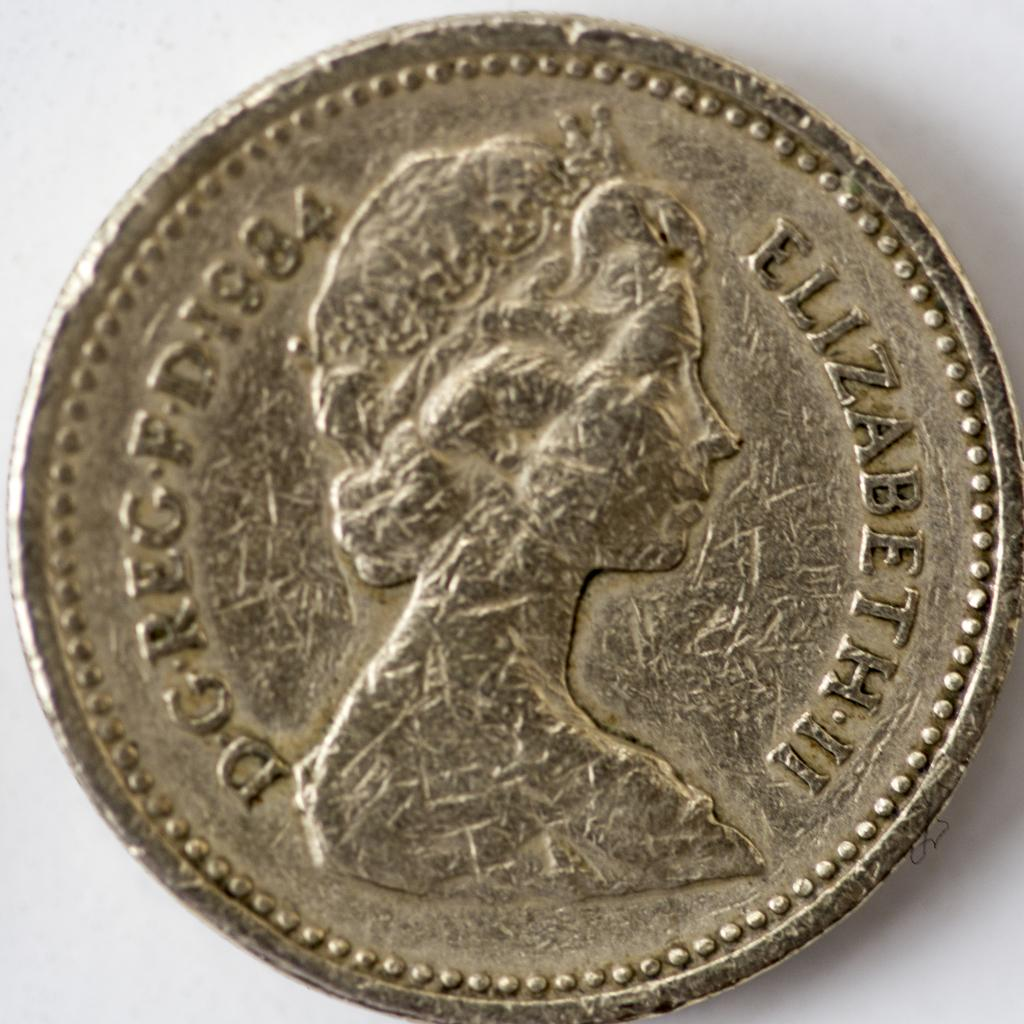Provide a one-sentence caption for the provided image. A coin with a woman on it with the word Elizabeth II is shown. 